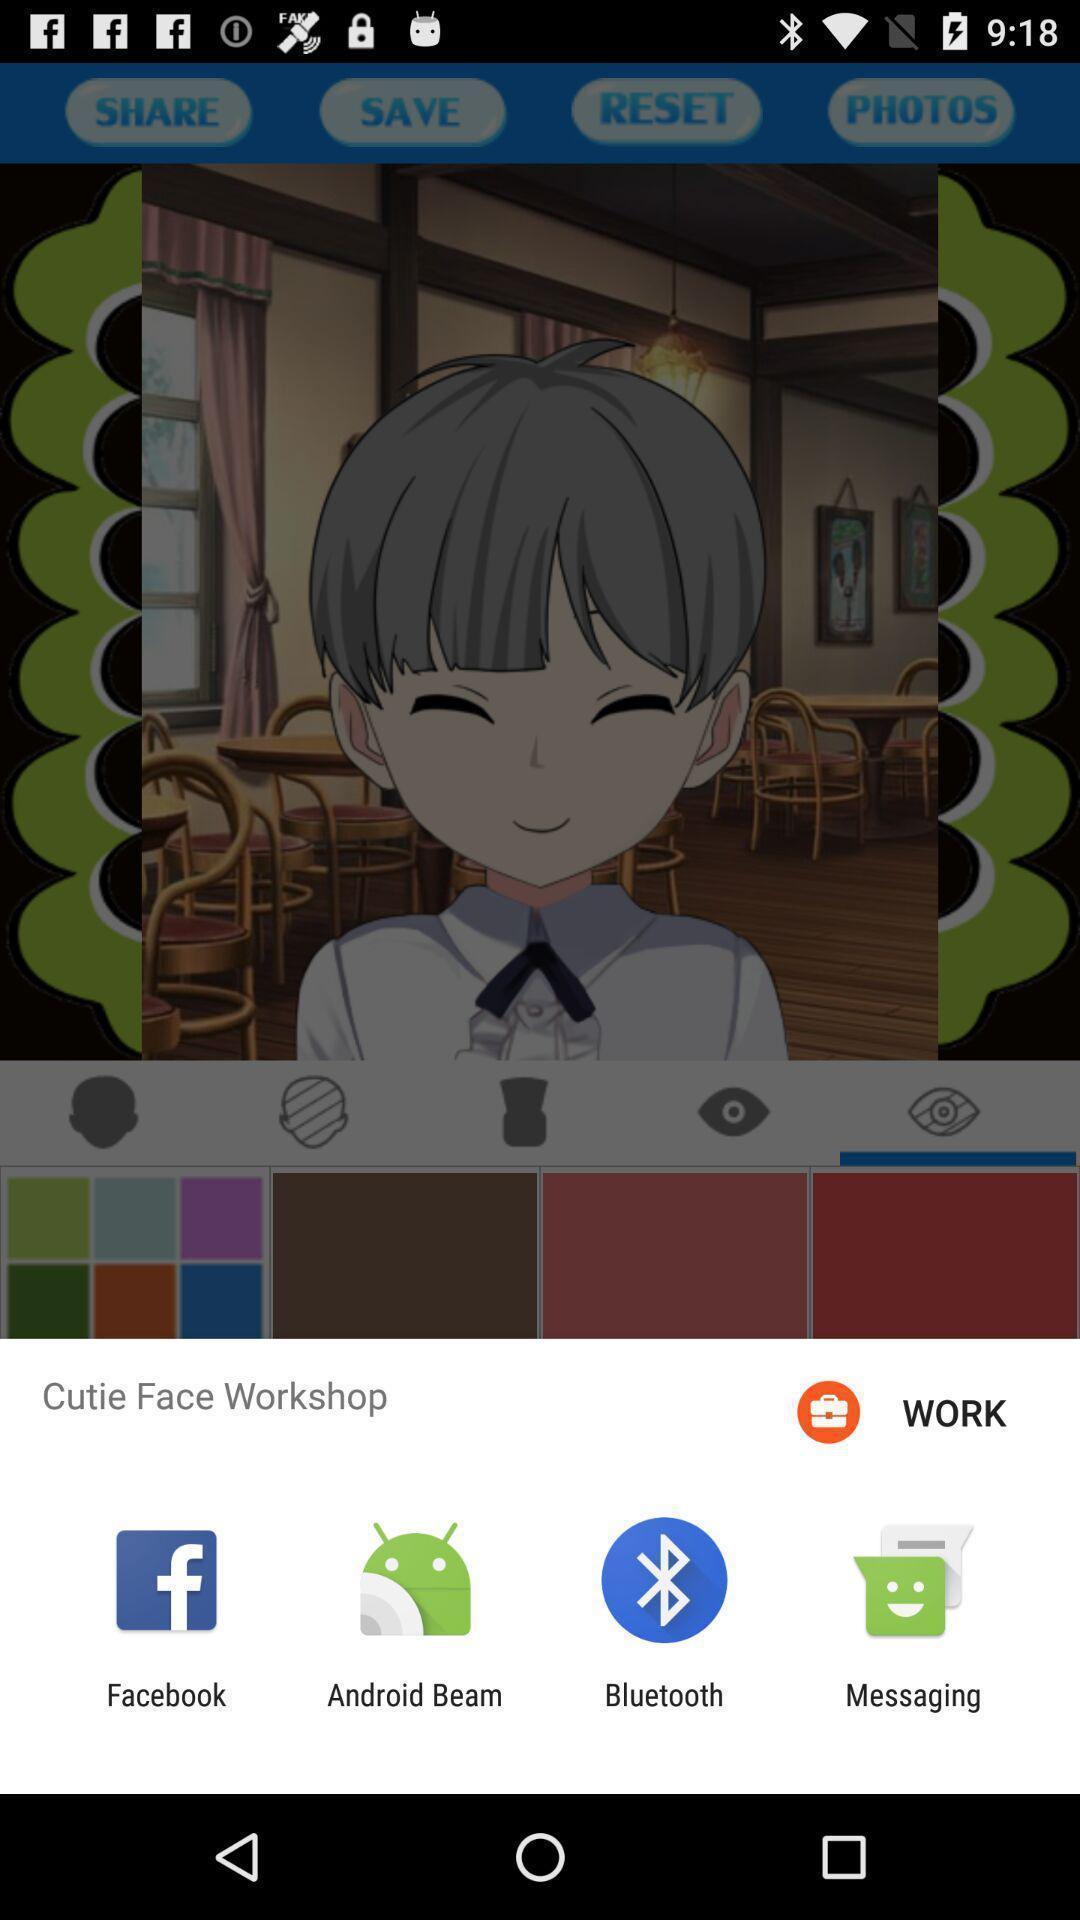Summarize the information in this screenshot. Share cutie face workshop with different apps. 